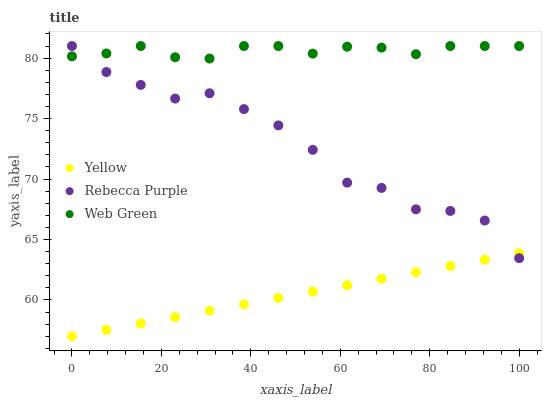Does Yellow have the minimum area under the curve?
Answer yes or no. Yes. Does Web Green have the maximum area under the curve?
Answer yes or no. Yes. Does Rebecca Purple have the minimum area under the curve?
Answer yes or no. No. Does Rebecca Purple have the maximum area under the curve?
Answer yes or no. No. Is Yellow the smoothest?
Answer yes or no. Yes. Is Rebecca Purple the roughest?
Answer yes or no. Yes. Is Rebecca Purple the smoothest?
Answer yes or no. No. Is Yellow the roughest?
Answer yes or no. No. Does Yellow have the lowest value?
Answer yes or no. Yes. Does Rebecca Purple have the lowest value?
Answer yes or no. No. Does Rebecca Purple have the highest value?
Answer yes or no. Yes. Does Yellow have the highest value?
Answer yes or no. No. Is Yellow less than Web Green?
Answer yes or no. Yes. Is Web Green greater than Yellow?
Answer yes or no. Yes. Does Rebecca Purple intersect Web Green?
Answer yes or no. Yes. Is Rebecca Purple less than Web Green?
Answer yes or no. No. Is Rebecca Purple greater than Web Green?
Answer yes or no. No. Does Yellow intersect Web Green?
Answer yes or no. No. 